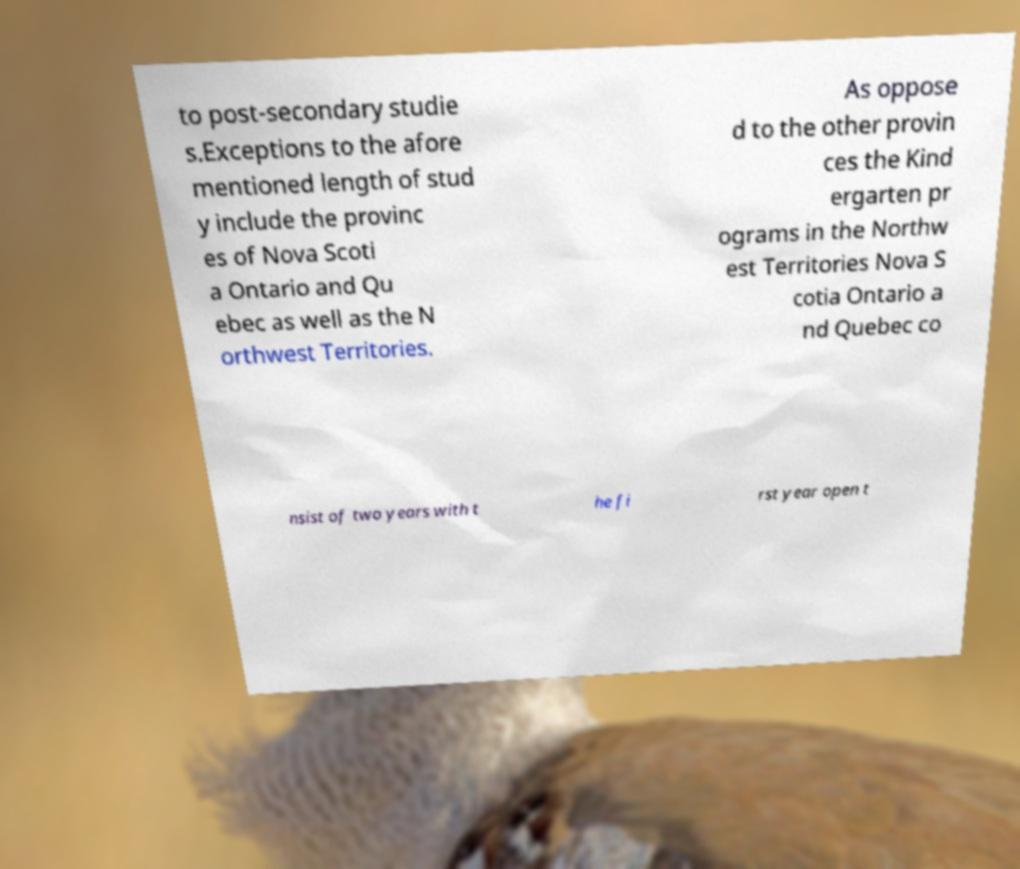Please read and relay the text visible in this image. What does it say? to post-secondary studie s.Exceptions to the afore mentioned length of stud y include the provinc es of Nova Scoti a Ontario and Qu ebec as well as the N orthwest Territories. As oppose d to the other provin ces the Kind ergarten pr ograms in the Northw est Territories Nova S cotia Ontario a nd Quebec co nsist of two years with t he fi rst year open t 